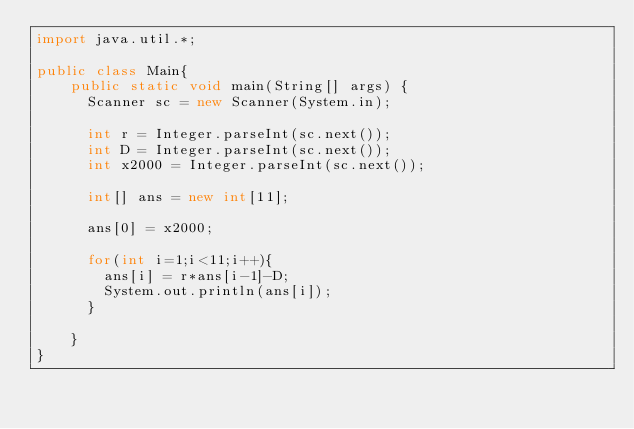Convert code to text. <code><loc_0><loc_0><loc_500><loc_500><_Java_>import java.util.*;

public class Main{
    public static void main(String[] args) {
      Scanner sc = new Scanner(System.in);

      int r = Integer.parseInt(sc.next());
      int D = Integer.parseInt(sc.next());
      int x2000 = Integer.parseInt(sc.next());

	  int[] ans = new int[11];
      
      ans[0] = x2000;
      
      for(int i=1;i<11;i++){
      	ans[i] = r*ans[i-1]-D;
       	System.out.println(ans[i]); 
      }

    }
}
</code> 